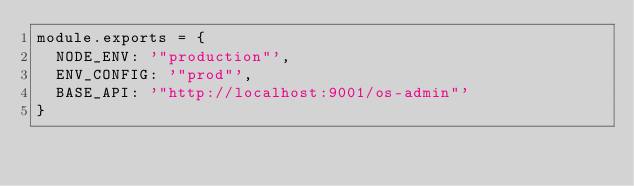Convert code to text. <code><loc_0><loc_0><loc_500><loc_500><_JavaScript_>module.exports = {
  NODE_ENV: '"production"',
  ENV_CONFIG: '"prod"',
  BASE_API: '"http://localhost:9001/os-admin"'
}
</code> 